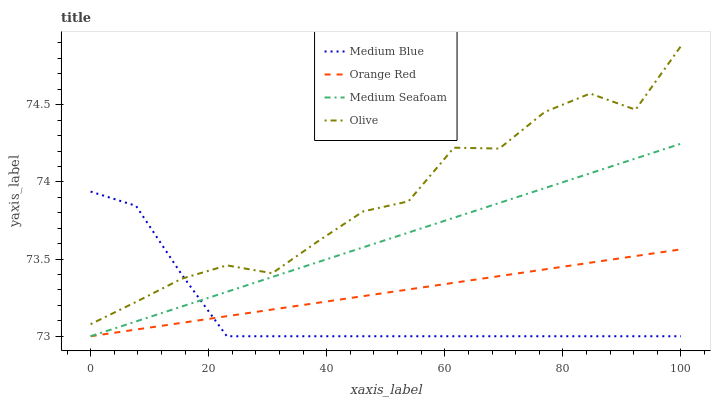Does Orange Red have the minimum area under the curve?
Answer yes or no. No. Does Orange Red have the maximum area under the curve?
Answer yes or no. No. Is Medium Blue the smoothest?
Answer yes or no. No. Is Medium Blue the roughest?
Answer yes or no. No. Does Medium Blue have the highest value?
Answer yes or no. No. Is Medium Seafoam less than Olive?
Answer yes or no. Yes. Is Olive greater than Medium Seafoam?
Answer yes or no. Yes. Does Medium Seafoam intersect Olive?
Answer yes or no. No. 